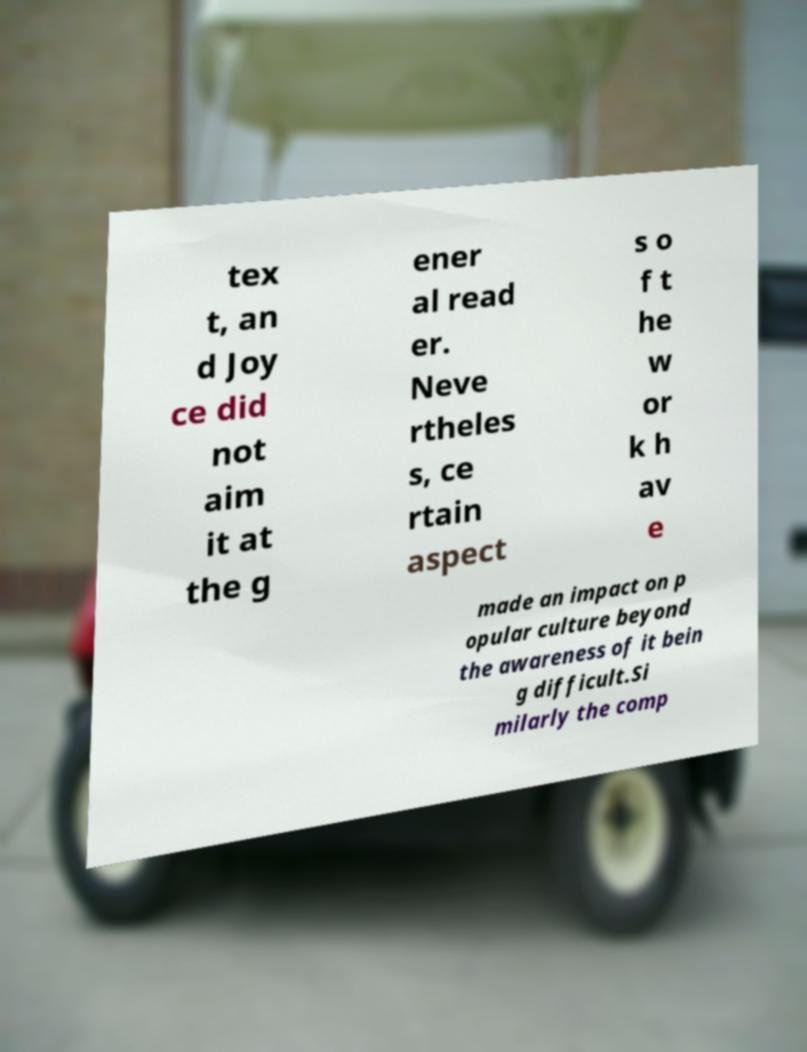I need the written content from this picture converted into text. Can you do that? tex t, an d Joy ce did not aim it at the g ener al read er. Neve rtheles s, ce rtain aspect s o f t he w or k h av e made an impact on p opular culture beyond the awareness of it bein g difficult.Si milarly the comp 